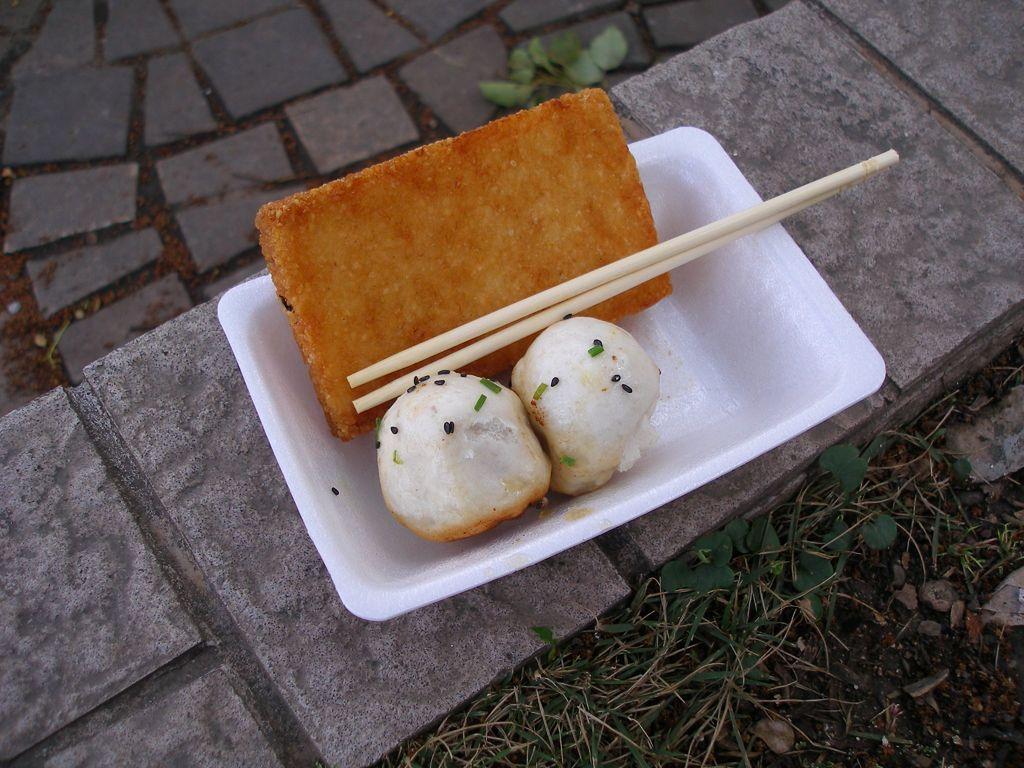Can you describe this image briefly? In this picture we can see plants, stones and a white bowl with food items, chopsticks in it and this bowl is placed on a surface. 